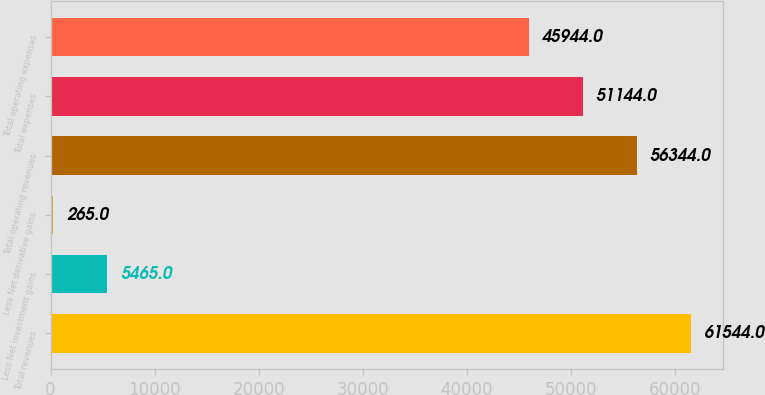<chart> <loc_0><loc_0><loc_500><loc_500><bar_chart><fcel>Total revenues<fcel>Less Net investment gains<fcel>Less Net derivative gains<fcel>Total operating revenues<fcel>Total expenses<fcel>Total operating expenses<nl><fcel>61544<fcel>5465<fcel>265<fcel>56344<fcel>51144<fcel>45944<nl></chart> 